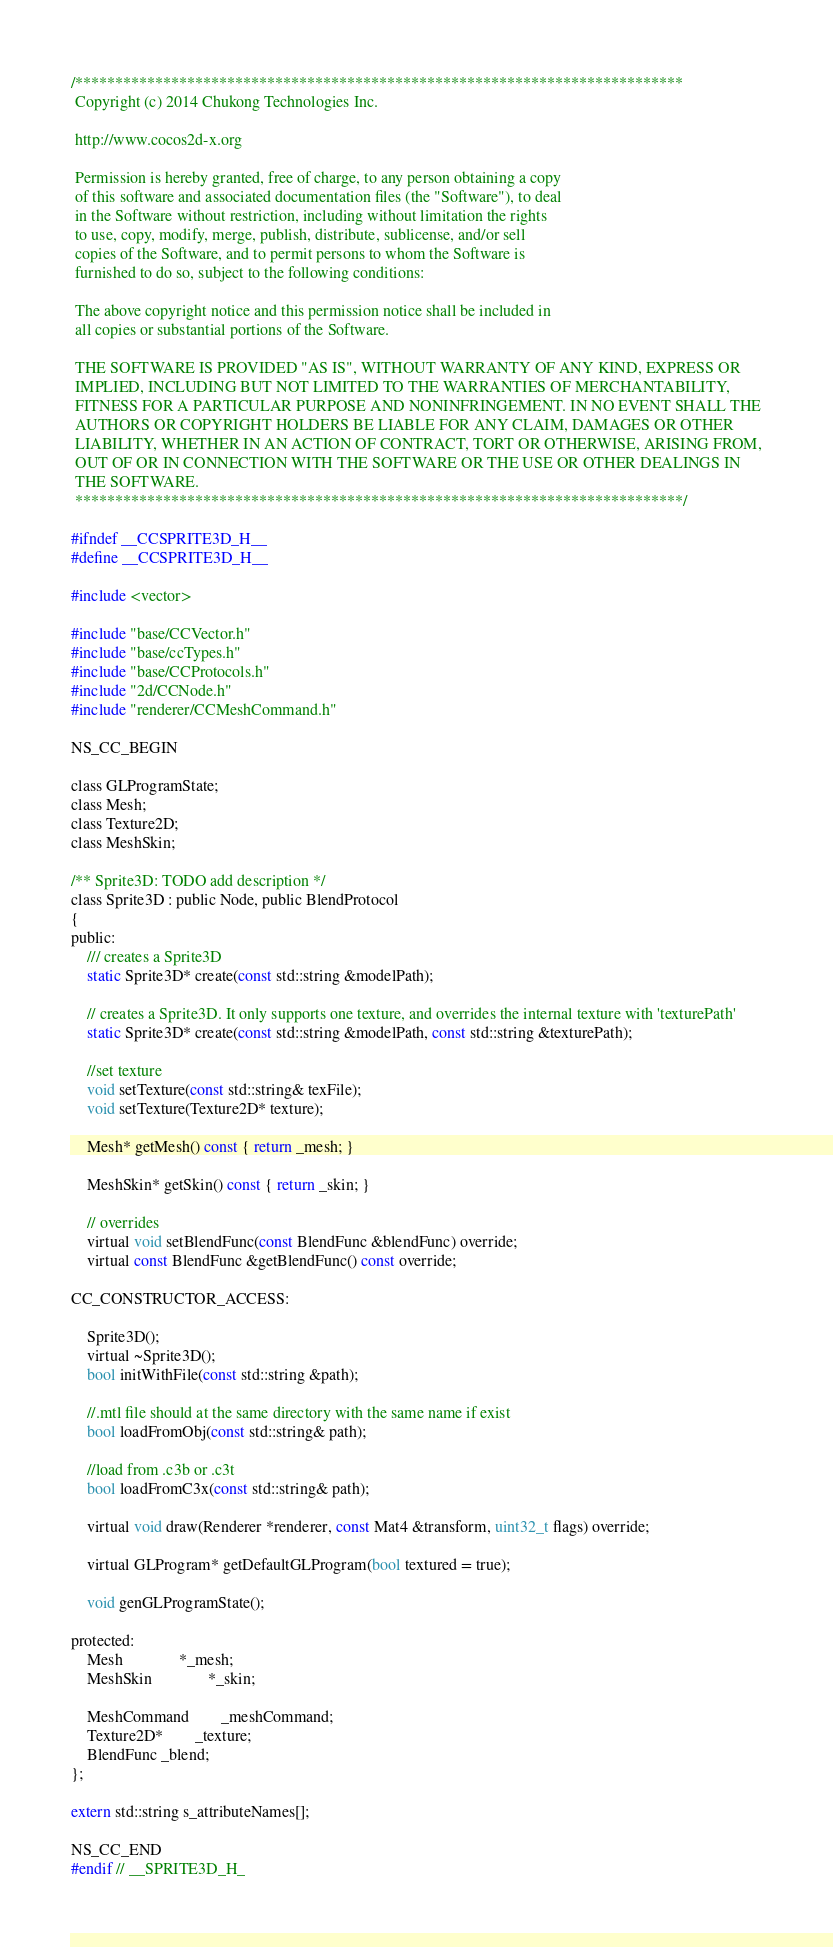Convert code to text. <code><loc_0><loc_0><loc_500><loc_500><_C_>/****************************************************************************
 Copyright (c) 2014 Chukong Technologies Inc.

 http://www.cocos2d-x.org

 Permission is hereby granted, free of charge, to any person obtaining a copy
 of this software and associated documentation files (the "Software"), to deal
 in the Software without restriction, including without limitation the rights
 to use, copy, modify, merge, publish, distribute, sublicense, and/or sell
 copies of the Software, and to permit persons to whom the Software is
 furnished to do so, subject to the following conditions:

 The above copyright notice and this permission notice shall be included in
 all copies or substantial portions of the Software.

 THE SOFTWARE IS PROVIDED "AS IS", WITHOUT WARRANTY OF ANY KIND, EXPRESS OR
 IMPLIED, INCLUDING BUT NOT LIMITED TO THE WARRANTIES OF MERCHANTABILITY,
 FITNESS FOR A PARTICULAR PURPOSE AND NONINFRINGEMENT. IN NO EVENT SHALL THE
 AUTHORS OR COPYRIGHT HOLDERS BE LIABLE FOR ANY CLAIM, DAMAGES OR OTHER
 LIABILITY, WHETHER IN AN ACTION OF CONTRACT, TORT OR OTHERWISE, ARISING FROM,
 OUT OF OR IN CONNECTION WITH THE SOFTWARE OR THE USE OR OTHER DEALINGS IN
 THE SOFTWARE.
 ****************************************************************************/

#ifndef __CCSPRITE3D_H__
#define __CCSPRITE3D_H__

#include <vector>

#include "base/CCVector.h"
#include "base/ccTypes.h"
#include "base/CCProtocols.h"
#include "2d/CCNode.h"
#include "renderer/CCMeshCommand.h"

NS_CC_BEGIN

class GLProgramState;
class Mesh;
class Texture2D;
class MeshSkin;

/** Sprite3D: TODO add description */
class Sprite3D : public Node, public BlendProtocol
{
public:
    /// creates a Sprite3D
    static Sprite3D* create(const std::string &modelPath);

    // creates a Sprite3D. It only supports one texture, and overrides the internal texture with 'texturePath'
    static Sprite3D* create(const std::string &modelPath, const std::string &texturePath);
    
    //set texture
    void setTexture(const std::string& texFile);
    void setTexture(Texture2D* texture);

    Mesh* getMesh() const { return _mesh; }
    
    MeshSkin* getSkin() const { return _skin; }

    // overrides
    virtual void setBlendFunc(const BlendFunc &blendFunc) override;
    virtual const BlendFunc &getBlendFunc() const override;

CC_CONSTRUCTOR_ACCESS:
    
    Sprite3D();
    virtual ~Sprite3D();
    bool initWithFile(const std::string &path);
    
    //.mtl file should at the same directory with the same name if exist
    bool loadFromObj(const std::string& path);
    
    //load from .c3b or .c3t
    bool loadFromC3x(const std::string& path);

    virtual void draw(Renderer *renderer, const Mat4 &transform, uint32_t flags) override;
    
    virtual GLProgram* getDefaultGLProgram(bool textured = true);
    
    void genGLProgramState();

protected:
    Mesh              *_mesh;
    MeshSkin              *_skin;
    
    MeshCommand        _meshCommand;
    Texture2D*        _texture;
    BlendFunc _blend;
};

extern std::string s_attributeNames[];

NS_CC_END
#endif // __SPRITE3D_H_
</code> 